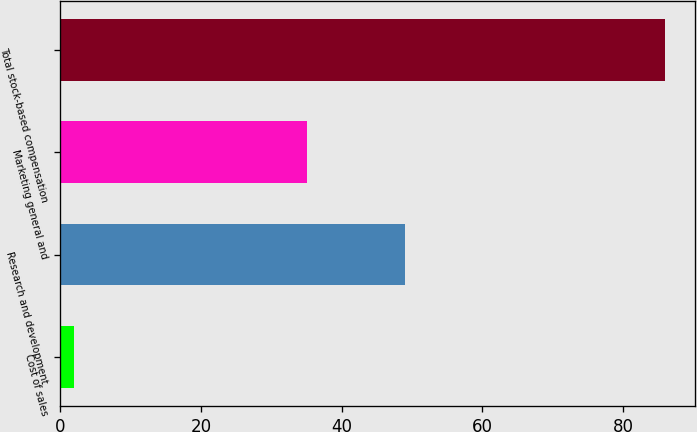Convert chart. <chart><loc_0><loc_0><loc_500><loc_500><bar_chart><fcel>Cost of sales<fcel>Research and development<fcel>Marketing general and<fcel>Total stock-based compensation<nl><fcel>2<fcel>49<fcel>35<fcel>86<nl></chart> 